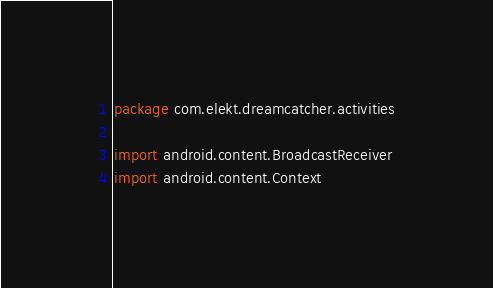Convert code to text. <code><loc_0><loc_0><loc_500><loc_500><_Kotlin_>package com.elekt.dreamcatcher.activities

import android.content.BroadcastReceiver
import android.content.Context</code> 